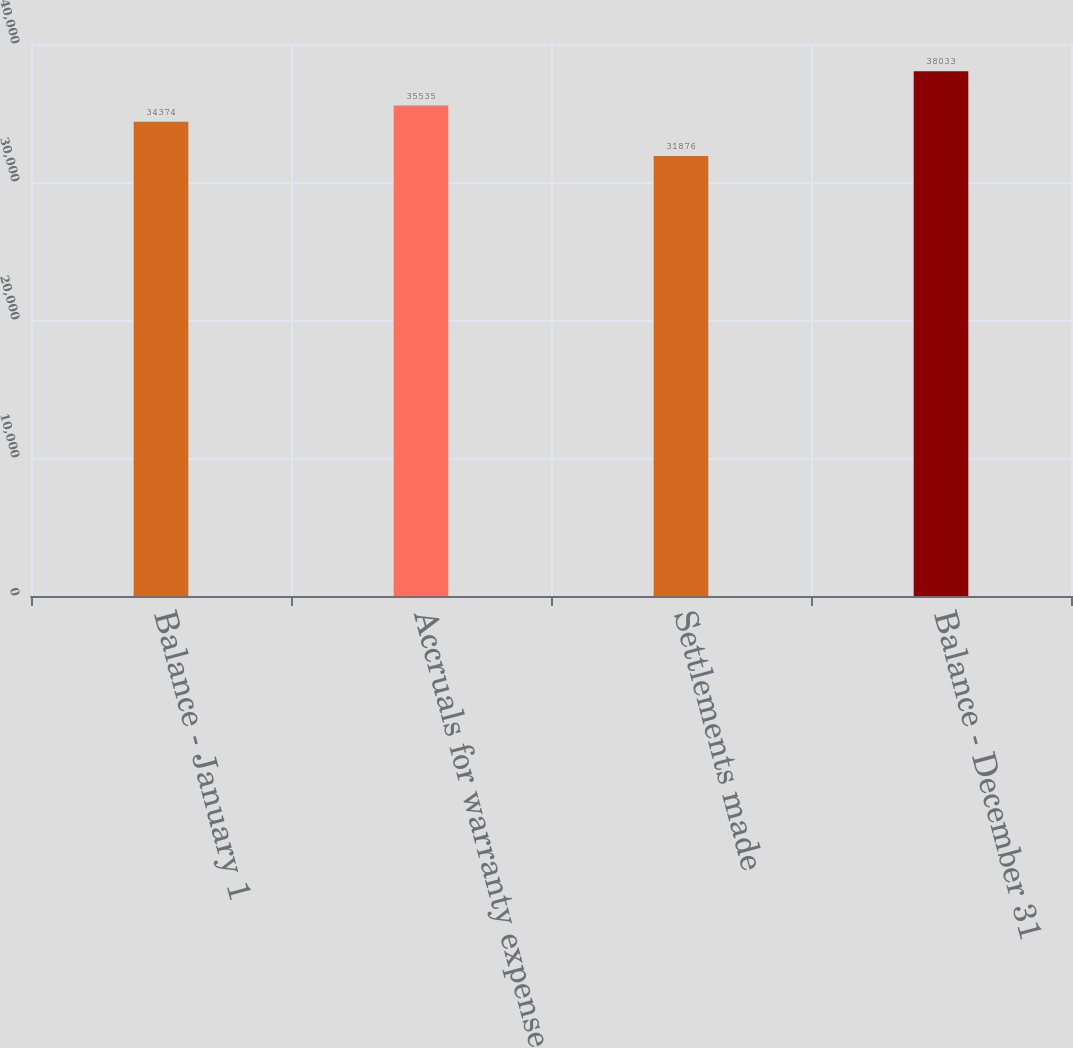Convert chart to OTSL. <chart><loc_0><loc_0><loc_500><loc_500><bar_chart><fcel>Balance - January 1<fcel>Accruals for warranty expense<fcel>Settlements made<fcel>Balance - December 31<nl><fcel>34374<fcel>35535<fcel>31876<fcel>38033<nl></chart> 